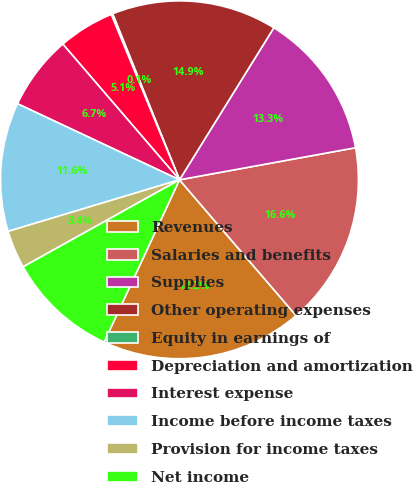<chart> <loc_0><loc_0><loc_500><loc_500><pie_chart><fcel>Revenues<fcel>Salaries and benefits<fcel>Supplies<fcel>Other operating expenses<fcel>Equity in earnings of<fcel>Depreciation and amortization<fcel>Interest expense<fcel>Income before income taxes<fcel>Provision for income taxes<fcel>Net income<nl><fcel>18.21%<fcel>16.57%<fcel>13.29%<fcel>14.93%<fcel>0.14%<fcel>5.07%<fcel>6.71%<fcel>11.64%<fcel>3.43%<fcel>10.0%<nl></chart> 